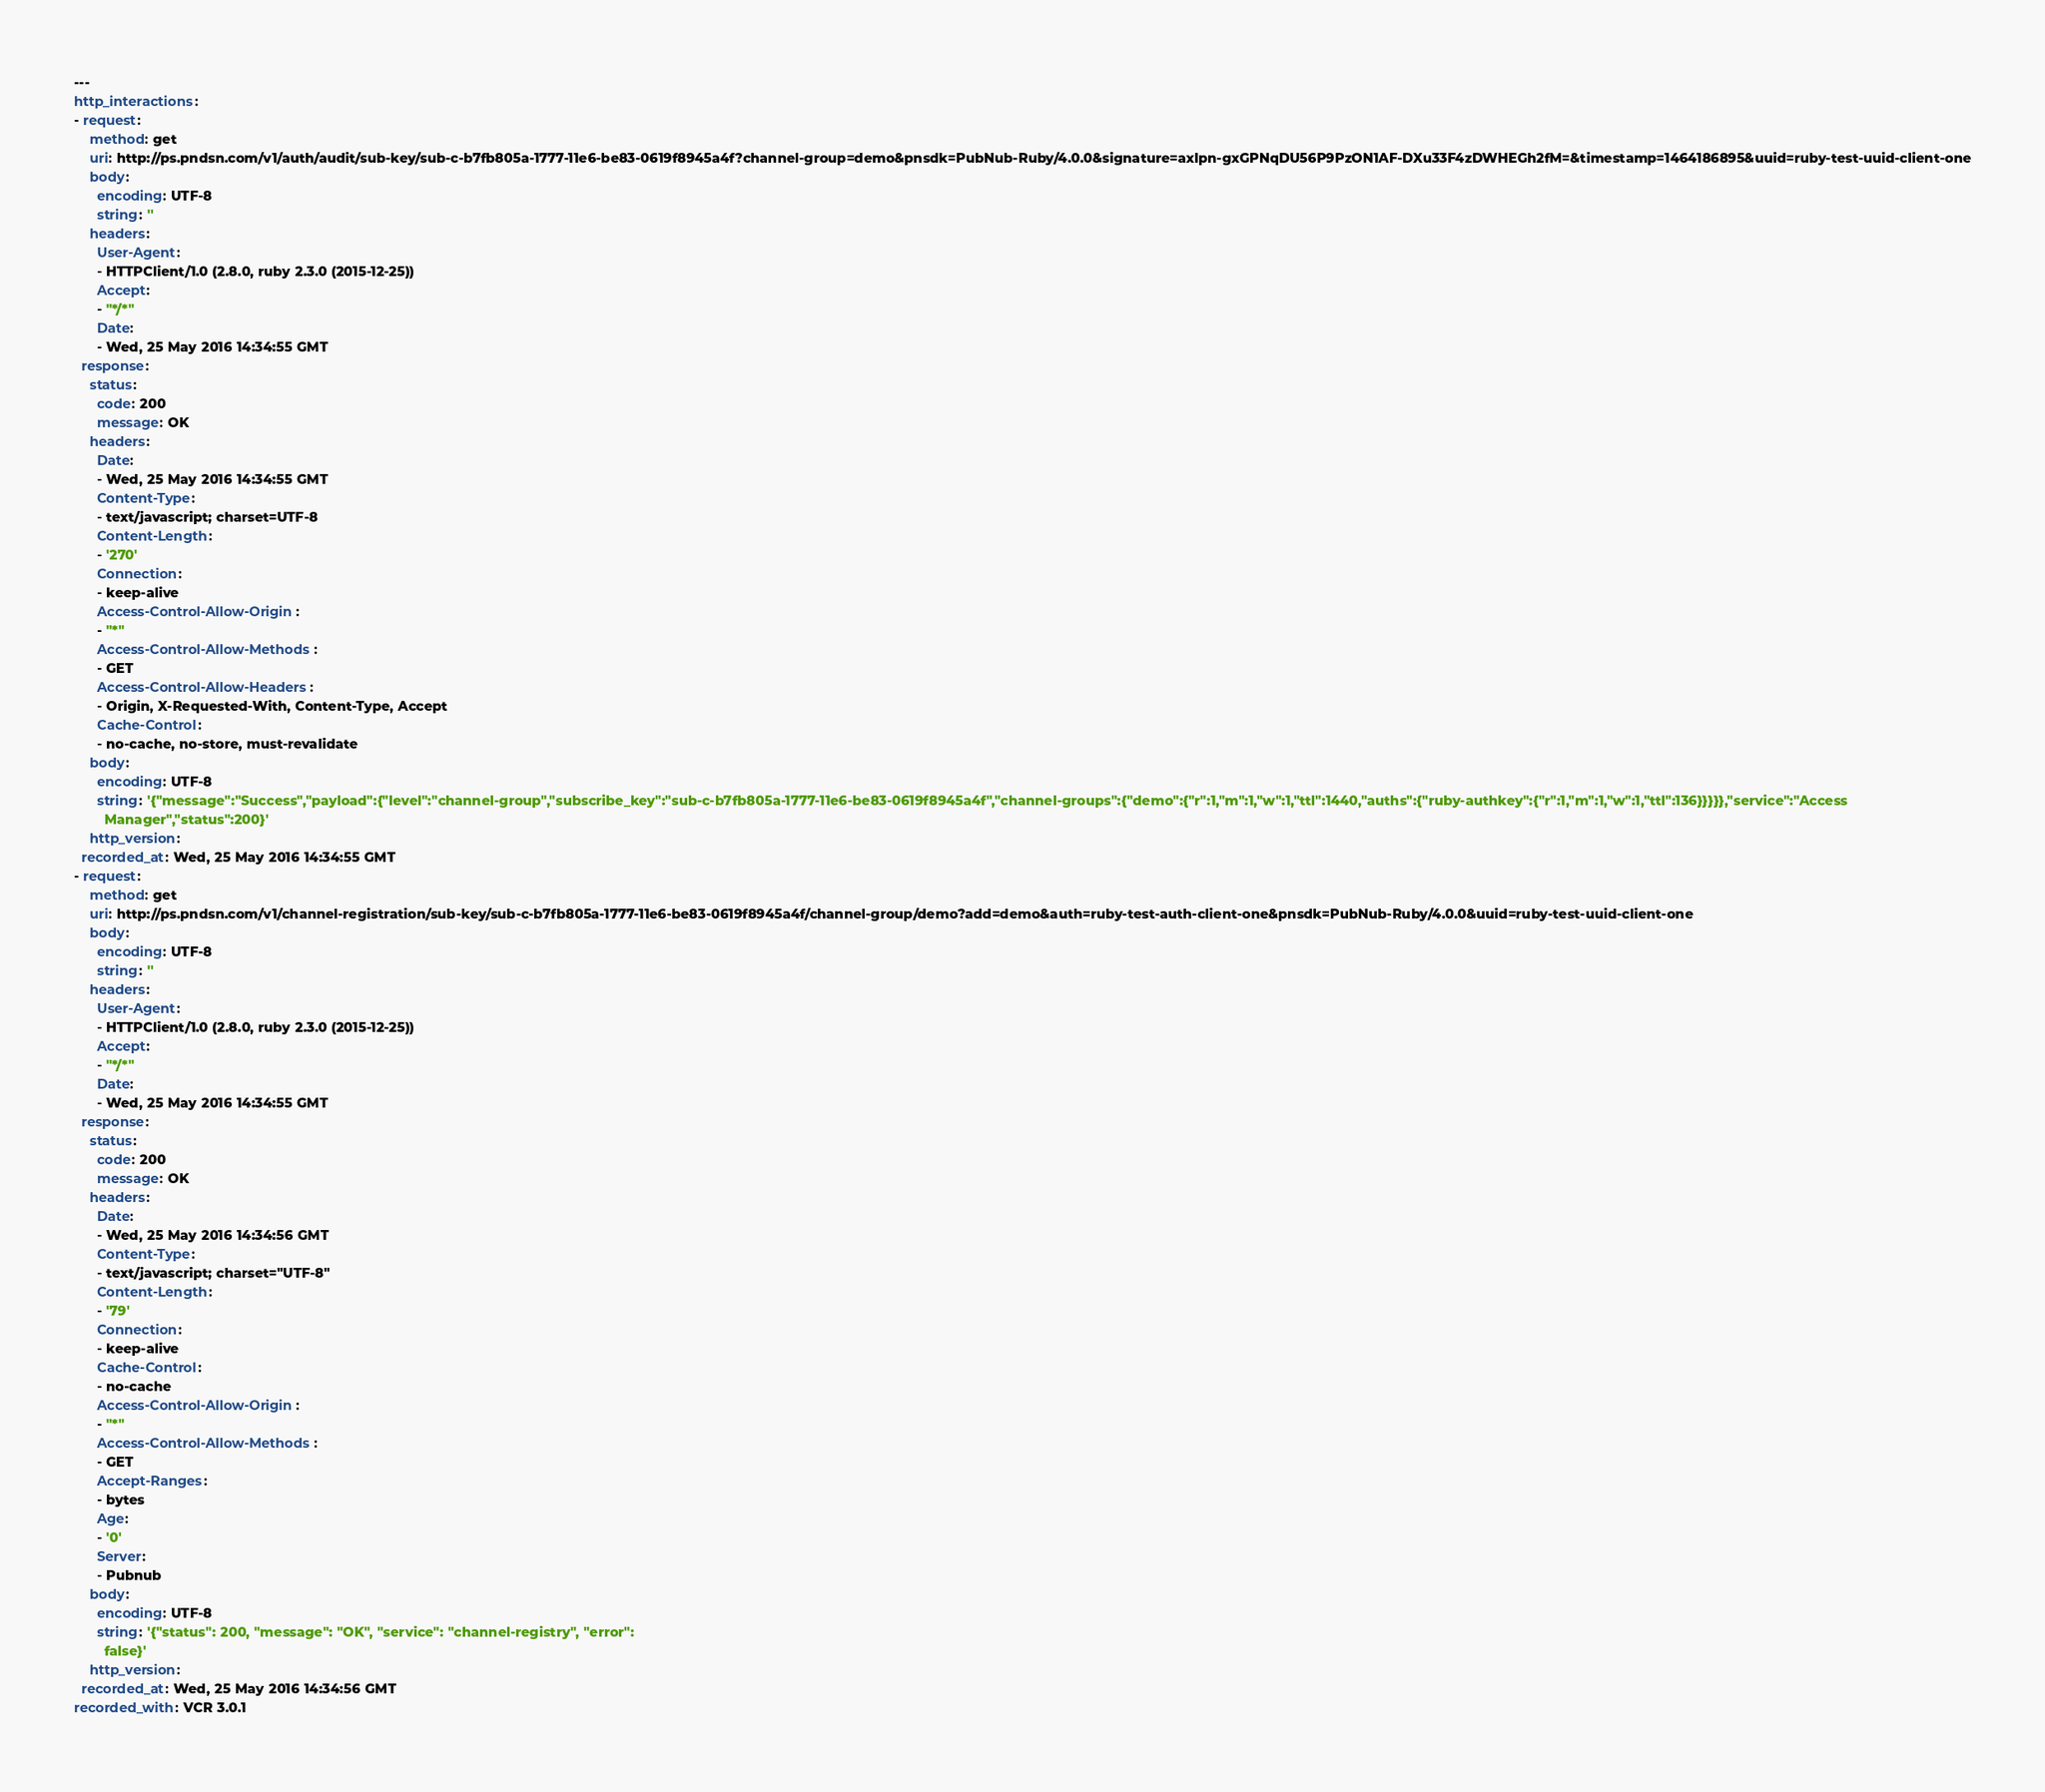<code> <loc_0><loc_0><loc_500><loc_500><_YAML_>---
http_interactions:
- request:
    method: get
    uri: http://ps.pndsn.com/v1/auth/audit/sub-key/sub-c-b7fb805a-1777-11e6-be83-0619f8945a4f?channel-group=demo&pnsdk=PubNub-Ruby/4.0.0&signature=axIpn-gxGPNqDU56P9PzON1AF-DXu33F4zDWHEGh2fM=&timestamp=1464186895&uuid=ruby-test-uuid-client-one
    body:
      encoding: UTF-8
      string: ''
    headers:
      User-Agent:
      - HTTPClient/1.0 (2.8.0, ruby 2.3.0 (2015-12-25))
      Accept:
      - "*/*"
      Date:
      - Wed, 25 May 2016 14:34:55 GMT
  response:
    status:
      code: 200
      message: OK
    headers:
      Date:
      - Wed, 25 May 2016 14:34:55 GMT
      Content-Type:
      - text/javascript; charset=UTF-8
      Content-Length:
      - '270'
      Connection:
      - keep-alive
      Access-Control-Allow-Origin:
      - "*"
      Access-Control-Allow-Methods:
      - GET
      Access-Control-Allow-Headers:
      - Origin, X-Requested-With, Content-Type, Accept
      Cache-Control:
      - no-cache, no-store, must-revalidate
    body:
      encoding: UTF-8
      string: '{"message":"Success","payload":{"level":"channel-group","subscribe_key":"sub-c-b7fb805a-1777-11e6-be83-0619f8945a4f","channel-groups":{"demo":{"r":1,"m":1,"w":1,"ttl":1440,"auths":{"ruby-authkey":{"r":1,"m":1,"w":1,"ttl":136}}}}},"service":"Access
        Manager","status":200}'
    http_version: 
  recorded_at: Wed, 25 May 2016 14:34:55 GMT
- request:
    method: get
    uri: http://ps.pndsn.com/v1/channel-registration/sub-key/sub-c-b7fb805a-1777-11e6-be83-0619f8945a4f/channel-group/demo?add=demo&auth=ruby-test-auth-client-one&pnsdk=PubNub-Ruby/4.0.0&uuid=ruby-test-uuid-client-one
    body:
      encoding: UTF-8
      string: ''
    headers:
      User-Agent:
      - HTTPClient/1.0 (2.8.0, ruby 2.3.0 (2015-12-25))
      Accept:
      - "*/*"
      Date:
      - Wed, 25 May 2016 14:34:55 GMT
  response:
    status:
      code: 200
      message: OK
    headers:
      Date:
      - Wed, 25 May 2016 14:34:56 GMT
      Content-Type:
      - text/javascript; charset="UTF-8"
      Content-Length:
      - '79'
      Connection:
      - keep-alive
      Cache-Control:
      - no-cache
      Access-Control-Allow-Origin:
      - "*"
      Access-Control-Allow-Methods:
      - GET
      Accept-Ranges:
      - bytes
      Age:
      - '0'
      Server:
      - Pubnub
    body:
      encoding: UTF-8
      string: '{"status": 200, "message": "OK", "service": "channel-registry", "error":
        false}'
    http_version: 
  recorded_at: Wed, 25 May 2016 14:34:56 GMT
recorded_with: VCR 3.0.1
</code> 